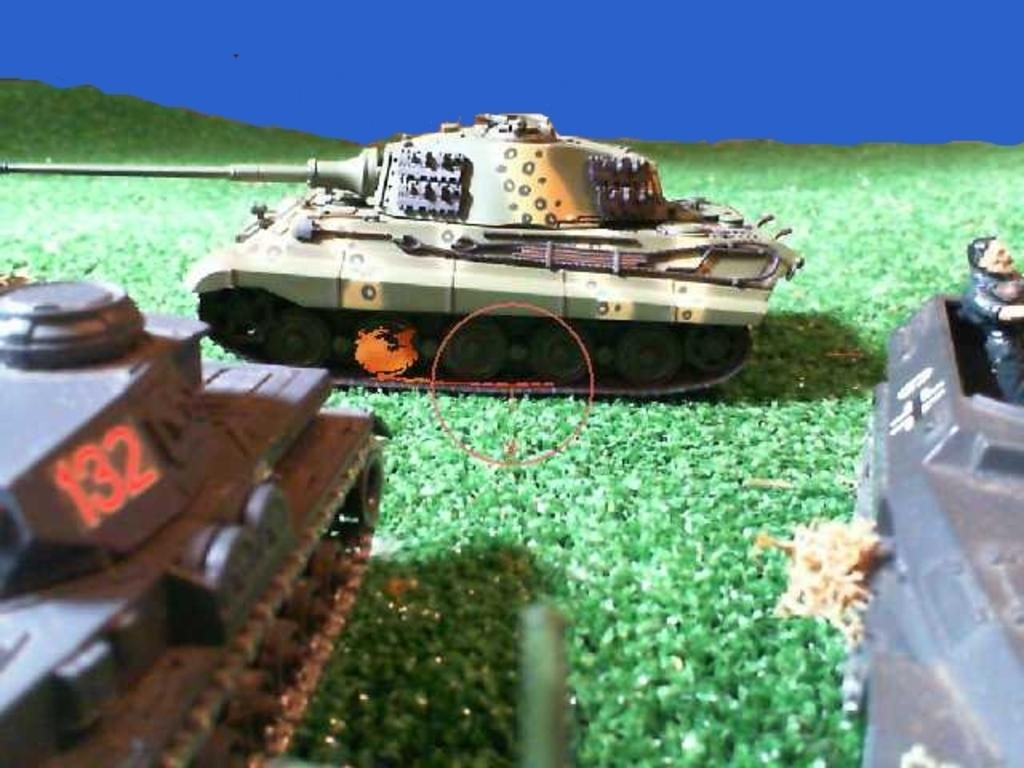What type of objects are in the image? There are toy vehicles in the image. What is the surface on which the toy vehicles are placed? The toy vehicles are placed on artificial grass. Can you see any fog in the image? There is no fog present in the image. Is there a sofa visible in the image? There is no sofa present in the image. Are there any crayons visible in the image? There is no mention of crayons in the provided facts, so we cannot determine if they are present in the image. 